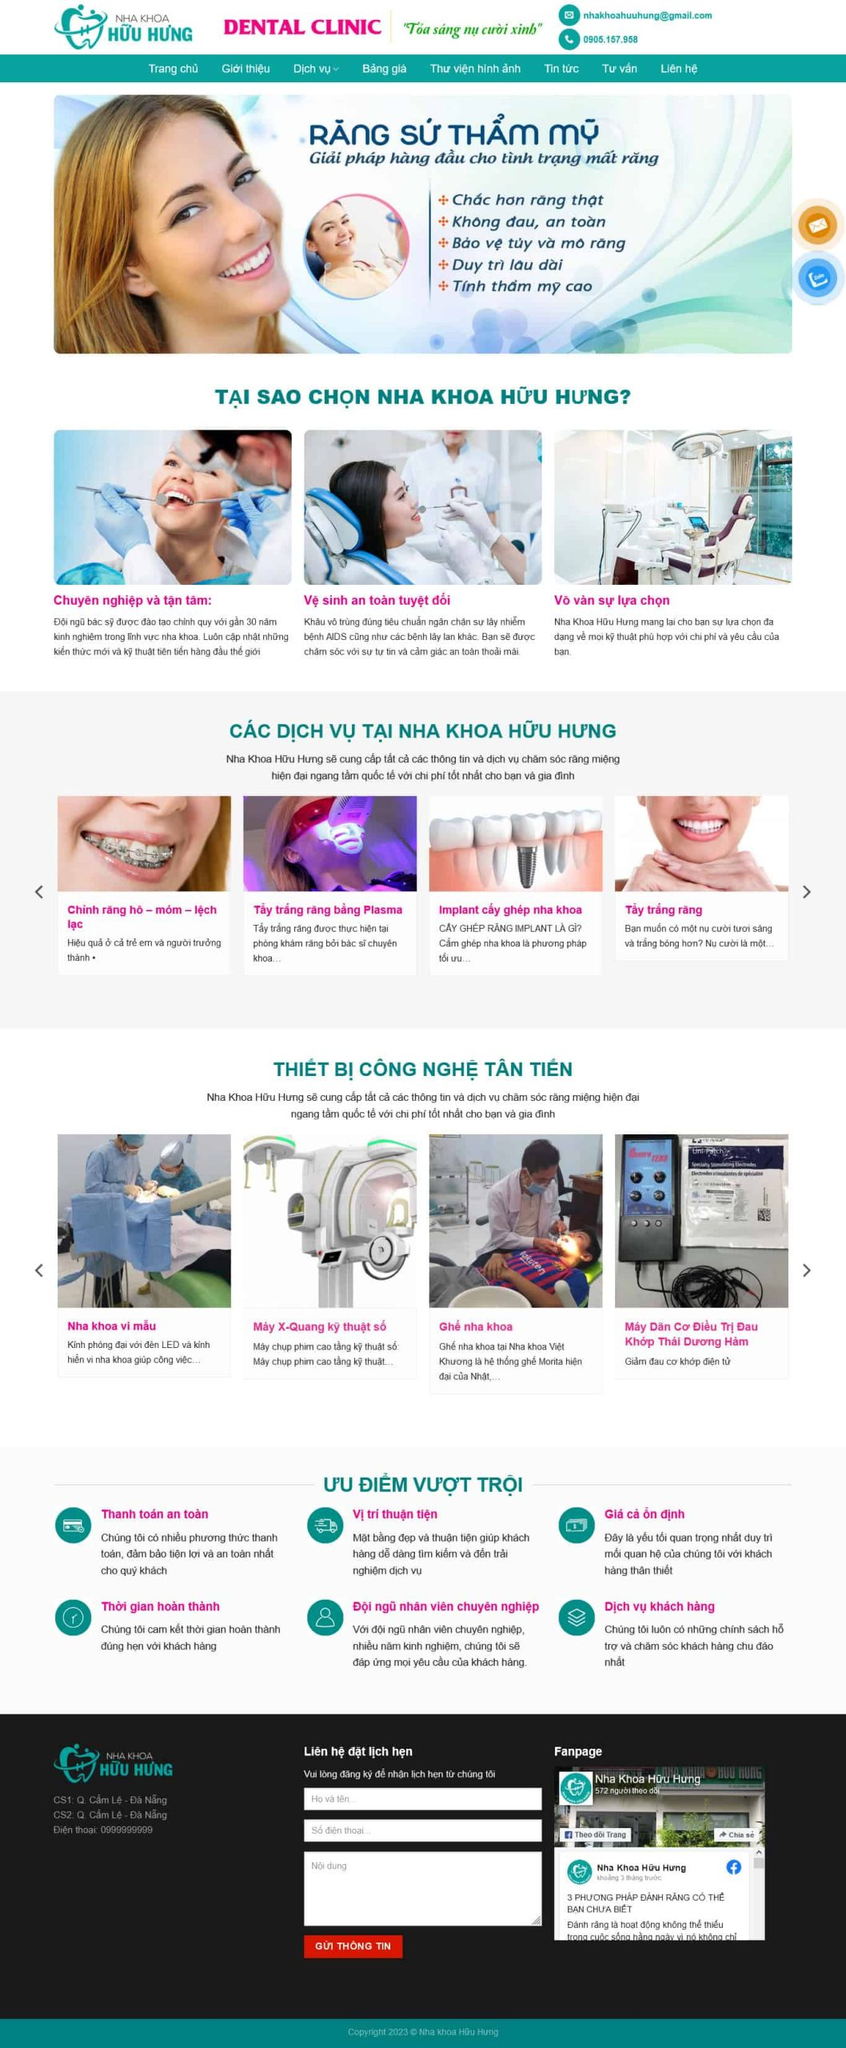Liệt kê 5 ngành nghề, lĩnh vực phù hợp với website này, phân cách các màu sắc bằng dấu phẩy. Chỉ trả về kết quả, phân cách bằng dấy phẩy
 Nha khoa, Y tế, Thẩm mỹ, Chăm sóc sức khỏe, Công nghệ y khoa 